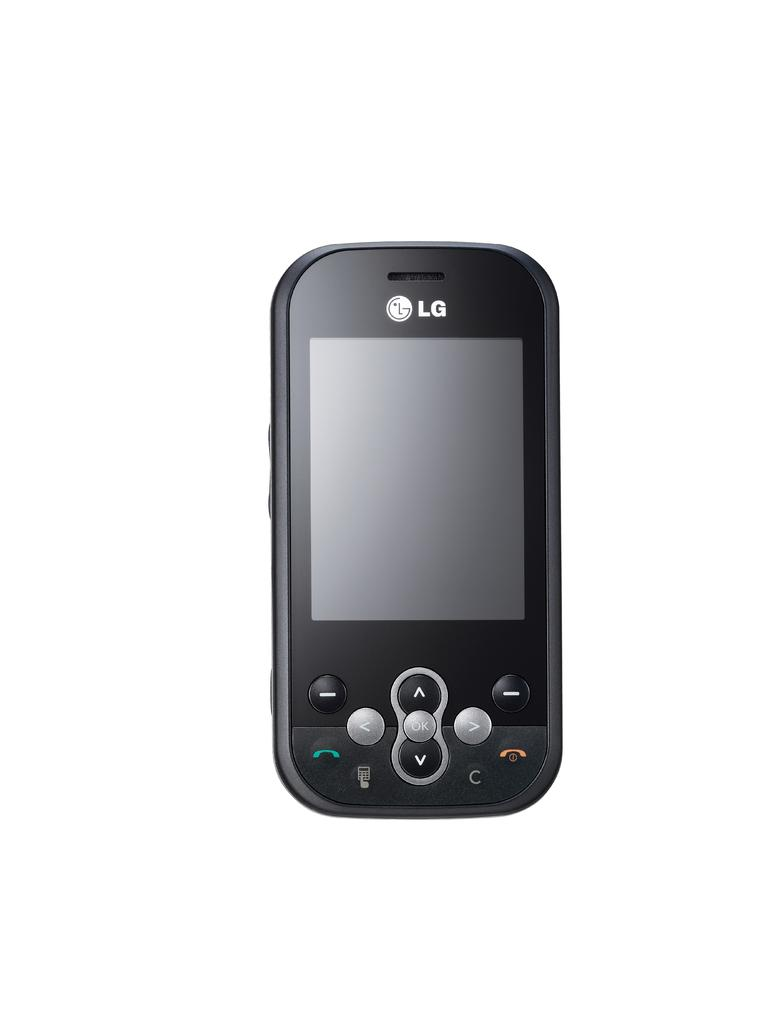<image>
Write a terse but informative summary of the picture. An LG phone with green and red buttons. 